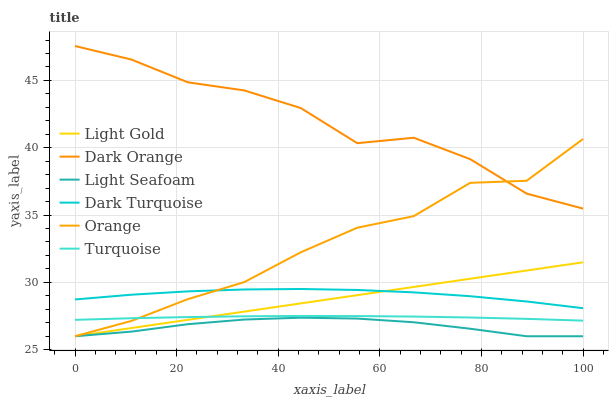Does Light Seafoam have the minimum area under the curve?
Answer yes or no. Yes. Does Dark Orange have the maximum area under the curve?
Answer yes or no. Yes. Does Turquoise have the minimum area under the curve?
Answer yes or no. No. Does Turquoise have the maximum area under the curve?
Answer yes or no. No. Is Light Gold the smoothest?
Answer yes or no. Yes. Is Dark Orange the roughest?
Answer yes or no. Yes. Is Turquoise the smoothest?
Answer yes or no. No. Is Turquoise the roughest?
Answer yes or no. No. Does Orange have the lowest value?
Answer yes or no. Yes. Does Turquoise have the lowest value?
Answer yes or no. No. Does Dark Orange have the highest value?
Answer yes or no. Yes. Does Turquoise have the highest value?
Answer yes or no. No. Is Light Seafoam less than Dark Turquoise?
Answer yes or no. Yes. Is Turquoise greater than Light Seafoam?
Answer yes or no. Yes. Does Light Gold intersect Dark Turquoise?
Answer yes or no. Yes. Is Light Gold less than Dark Turquoise?
Answer yes or no. No. Is Light Gold greater than Dark Turquoise?
Answer yes or no. No. Does Light Seafoam intersect Dark Turquoise?
Answer yes or no. No. 